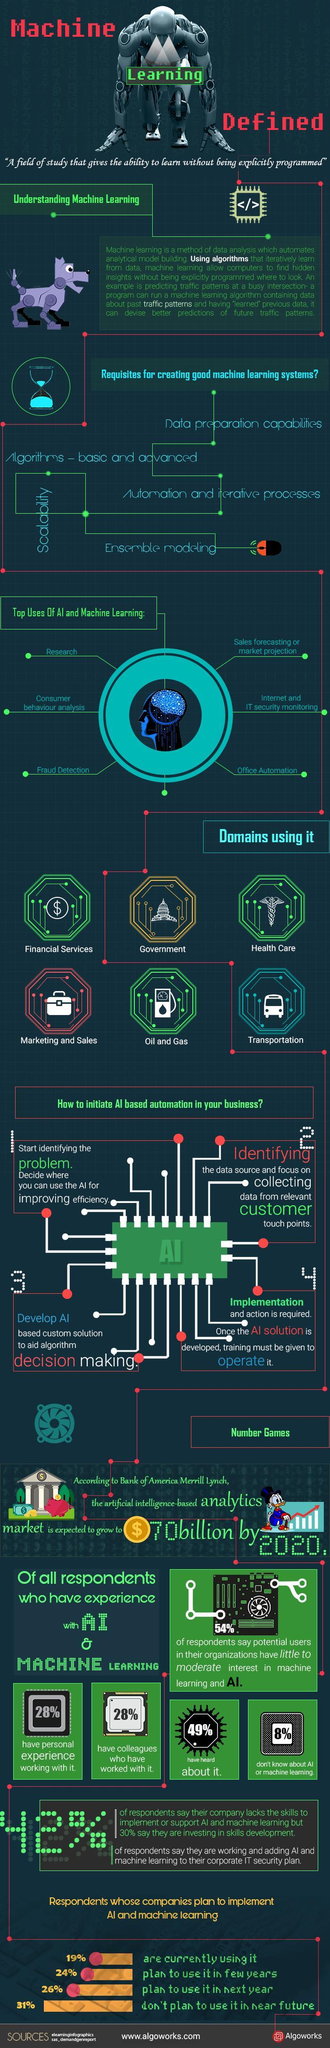How many requisites are listed for creating good machine learning systems?
Answer the question with a short phrase. 5 How many domains use AI? 6 What percent of respondents plan to use it next year and in few years? 50% How many top uses of AI and machine learning are given? 6 By how much will AI based analytics market grow? $ 70 billion What percent of people do not have personal experience working with AI? 72% What percentage says that their company lacks the skill to implement or support AI? 42% 